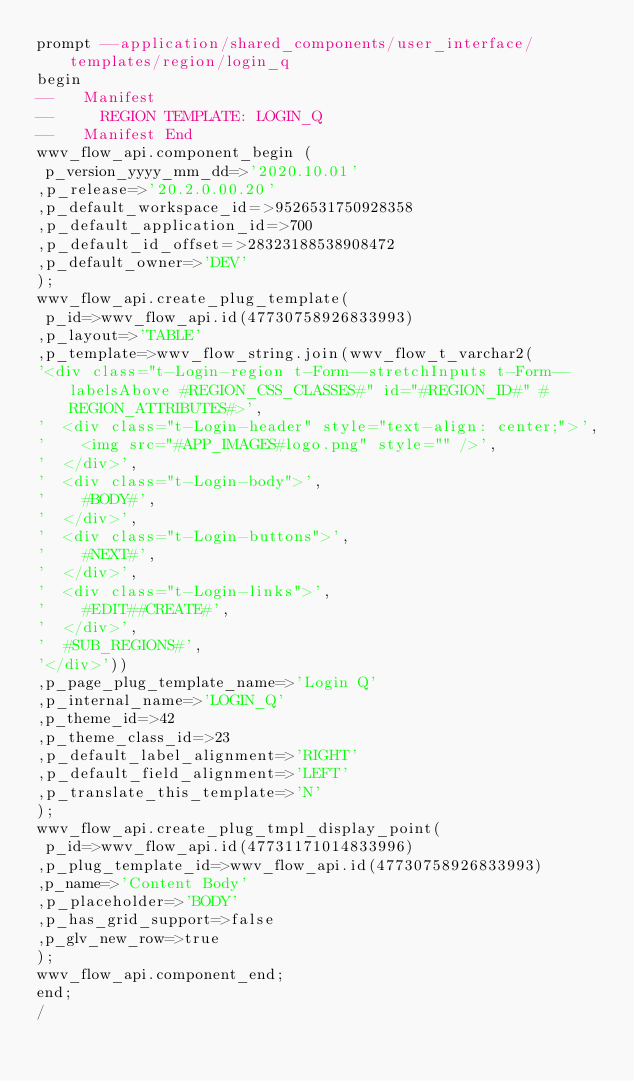Convert code to text. <code><loc_0><loc_0><loc_500><loc_500><_SQL_>prompt --application/shared_components/user_interface/templates/region/login_q
begin
--   Manifest
--     REGION TEMPLATE: LOGIN_Q
--   Manifest End
wwv_flow_api.component_begin (
 p_version_yyyy_mm_dd=>'2020.10.01'
,p_release=>'20.2.0.00.20'
,p_default_workspace_id=>9526531750928358
,p_default_application_id=>700
,p_default_id_offset=>28323188538908472
,p_default_owner=>'DEV'
);
wwv_flow_api.create_plug_template(
 p_id=>wwv_flow_api.id(47730758926833993)
,p_layout=>'TABLE'
,p_template=>wwv_flow_string.join(wwv_flow_t_varchar2(
'<div class="t-Login-region t-Form--stretchInputs t-Form--labelsAbove #REGION_CSS_CLASSES#" id="#REGION_ID#" #REGION_ATTRIBUTES#>',
'  <div class="t-Login-header" style="text-align: center;">',
'    <img src="#APP_IMAGES#logo.png" style="" />',
'  </div>',
'  <div class="t-Login-body">',
'    #BODY#',
'  </div>',
'  <div class="t-Login-buttons">',
'    #NEXT#',
'  </div>',
'  <div class="t-Login-links">',
'    #EDIT##CREATE#',
'  </div>',
'  #SUB_REGIONS#',
'</div>'))
,p_page_plug_template_name=>'Login Q'
,p_internal_name=>'LOGIN_Q'
,p_theme_id=>42
,p_theme_class_id=>23
,p_default_label_alignment=>'RIGHT'
,p_default_field_alignment=>'LEFT'
,p_translate_this_template=>'N'
);
wwv_flow_api.create_plug_tmpl_display_point(
 p_id=>wwv_flow_api.id(47731171014833996)
,p_plug_template_id=>wwv_flow_api.id(47730758926833993)
,p_name=>'Content Body'
,p_placeholder=>'BODY'
,p_has_grid_support=>false
,p_glv_new_row=>true
);
wwv_flow_api.component_end;
end;
/
</code> 